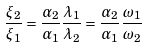Convert formula to latex. <formula><loc_0><loc_0><loc_500><loc_500>\frac { \xi _ { 2 } } { \xi _ { 1 } } = \frac { \alpha _ { 2 } } { \alpha _ { 1 } } \frac { \lambda _ { 1 } } { \lambda _ { 2 } } = \frac { \alpha _ { 2 } } { \alpha _ { 1 } } \frac { \omega _ { 1 } } { \omega _ { 2 } }</formula> 